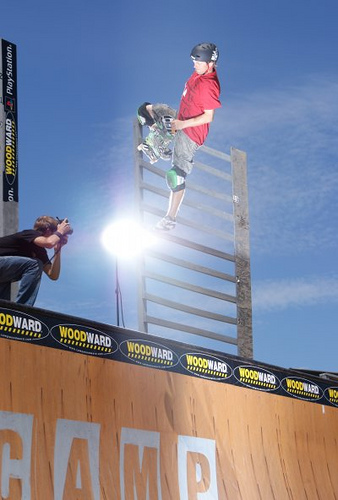Identify the text displayed in this image. ODWARD WOODWARD WOODWARD WOODWARD CAMP WOODWARD WARD Playstation 